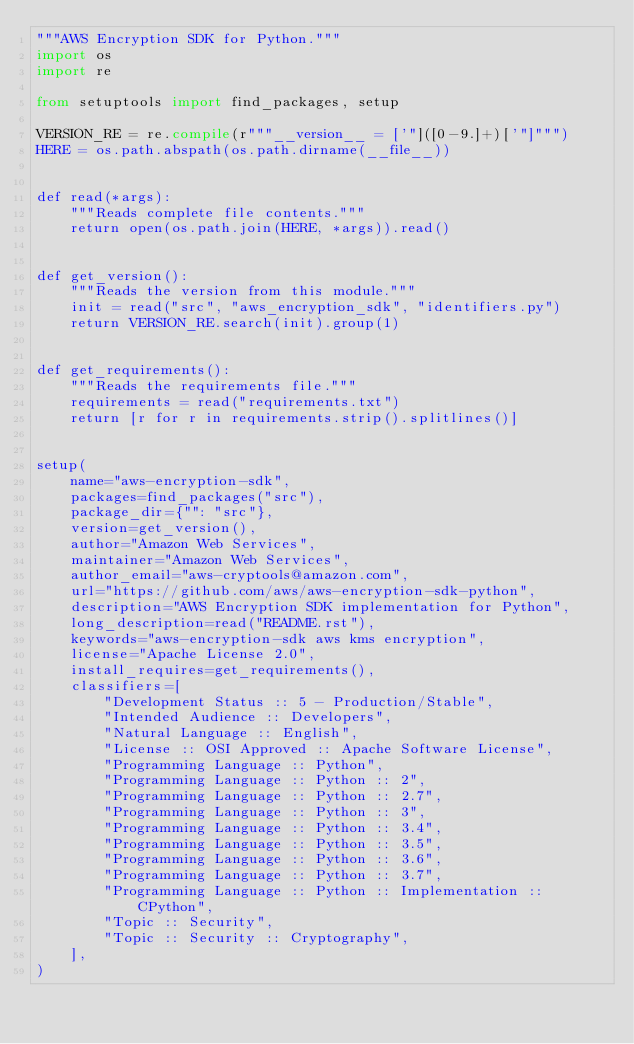<code> <loc_0><loc_0><loc_500><loc_500><_Python_>"""AWS Encryption SDK for Python."""
import os
import re

from setuptools import find_packages, setup

VERSION_RE = re.compile(r"""__version__ = ['"]([0-9.]+)['"]""")
HERE = os.path.abspath(os.path.dirname(__file__))


def read(*args):
    """Reads complete file contents."""
    return open(os.path.join(HERE, *args)).read()


def get_version():
    """Reads the version from this module."""
    init = read("src", "aws_encryption_sdk", "identifiers.py")
    return VERSION_RE.search(init).group(1)


def get_requirements():
    """Reads the requirements file."""
    requirements = read("requirements.txt")
    return [r for r in requirements.strip().splitlines()]


setup(
    name="aws-encryption-sdk",
    packages=find_packages("src"),
    package_dir={"": "src"},
    version=get_version(),
    author="Amazon Web Services",
    maintainer="Amazon Web Services",
    author_email="aws-cryptools@amazon.com",
    url="https://github.com/aws/aws-encryption-sdk-python",
    description="AWS Encryption SDK implementation for Python",
    long_description=read("README.rst"),
    keywords="aws-encryption-sdk aws kms encryption",
    license="Apache License 2.0",
    install_requires=get_requirements(),
    classifiers=[
        "Development Status :: 5 - Production/Stable",
        "Intended Audience :: Developers",
        "Natural Language :: English",
        "License :: OSI Approved :: Apache Software License",
        "Programming Language :: Python",
        "Programming Language :: Python :: 2",
        "Programming Language :: Python :: 2.7",
        "Programming Language :: Python :: 3",
        "Programming Language :: Python :: 3.4",
        "Programming Language :: Python :: 3.5",
        "Programming Language :: Python :: 3.6",
        "Programming Language :: Python :: 3.7",
        "Programming Language :: Python :: Implementation :: CPython",
        "Topic :: Security",
        "Topic :: Security :: Cryptography",
    ],
)
</code> 